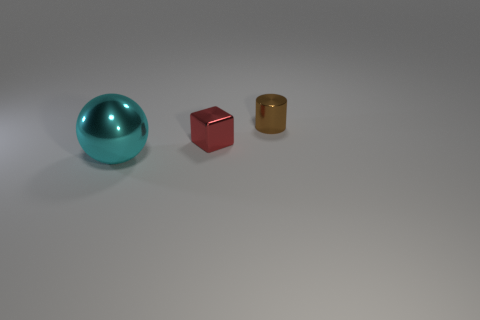Add 2 cyan things. How many objects exist? 5 Subtract all spheres. How many objects are left? 2 Add 2 small gray rubber objects. How many small gray rubber objects exist? 2 Subtract 0 purple cubes. How many objects are left? 3 Subtract all tiny red objects. Subtract all big cylinders. How many objects are left? 2 Add 3 brown shiny objects. How many brown shiny objects are left? 4 